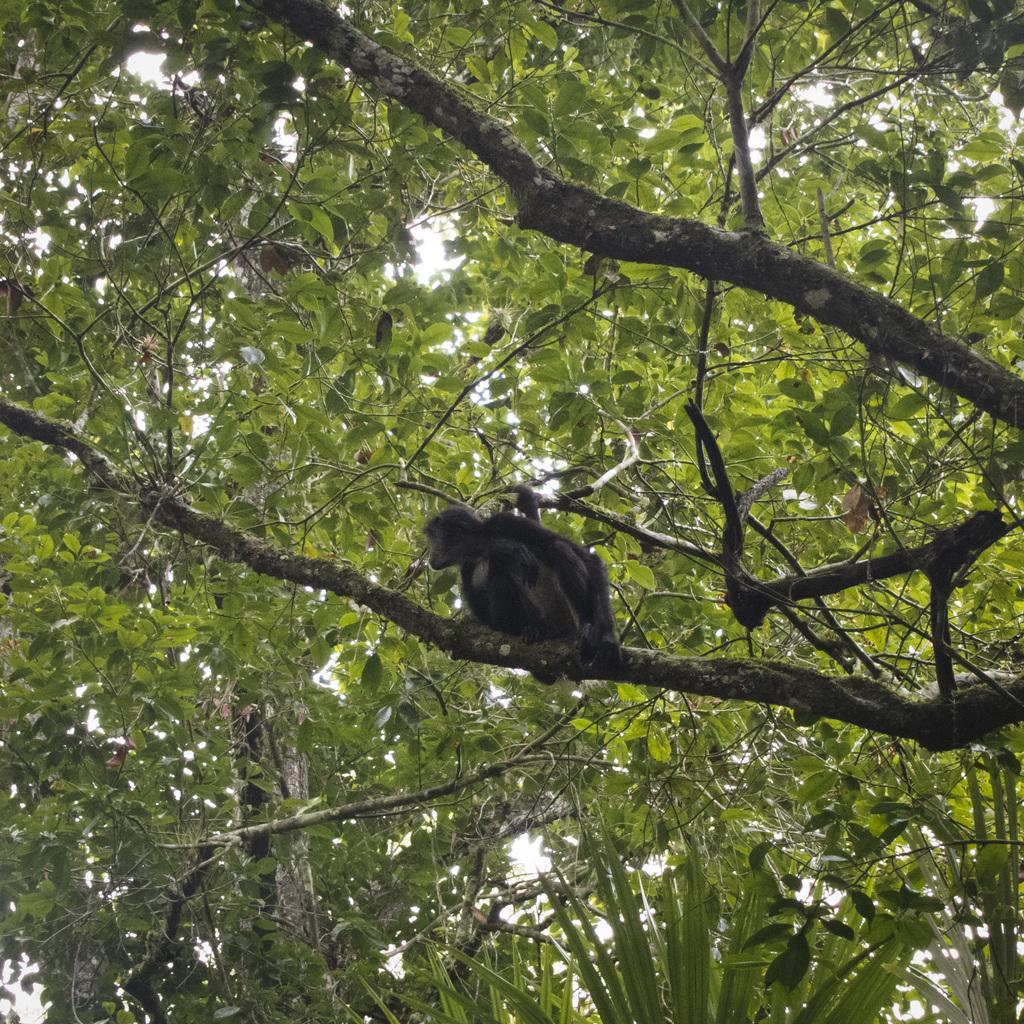How would you summarize this image in a sentence or two? In this picture there is a monkey on the tree and there are trees. At the top there is sky. 